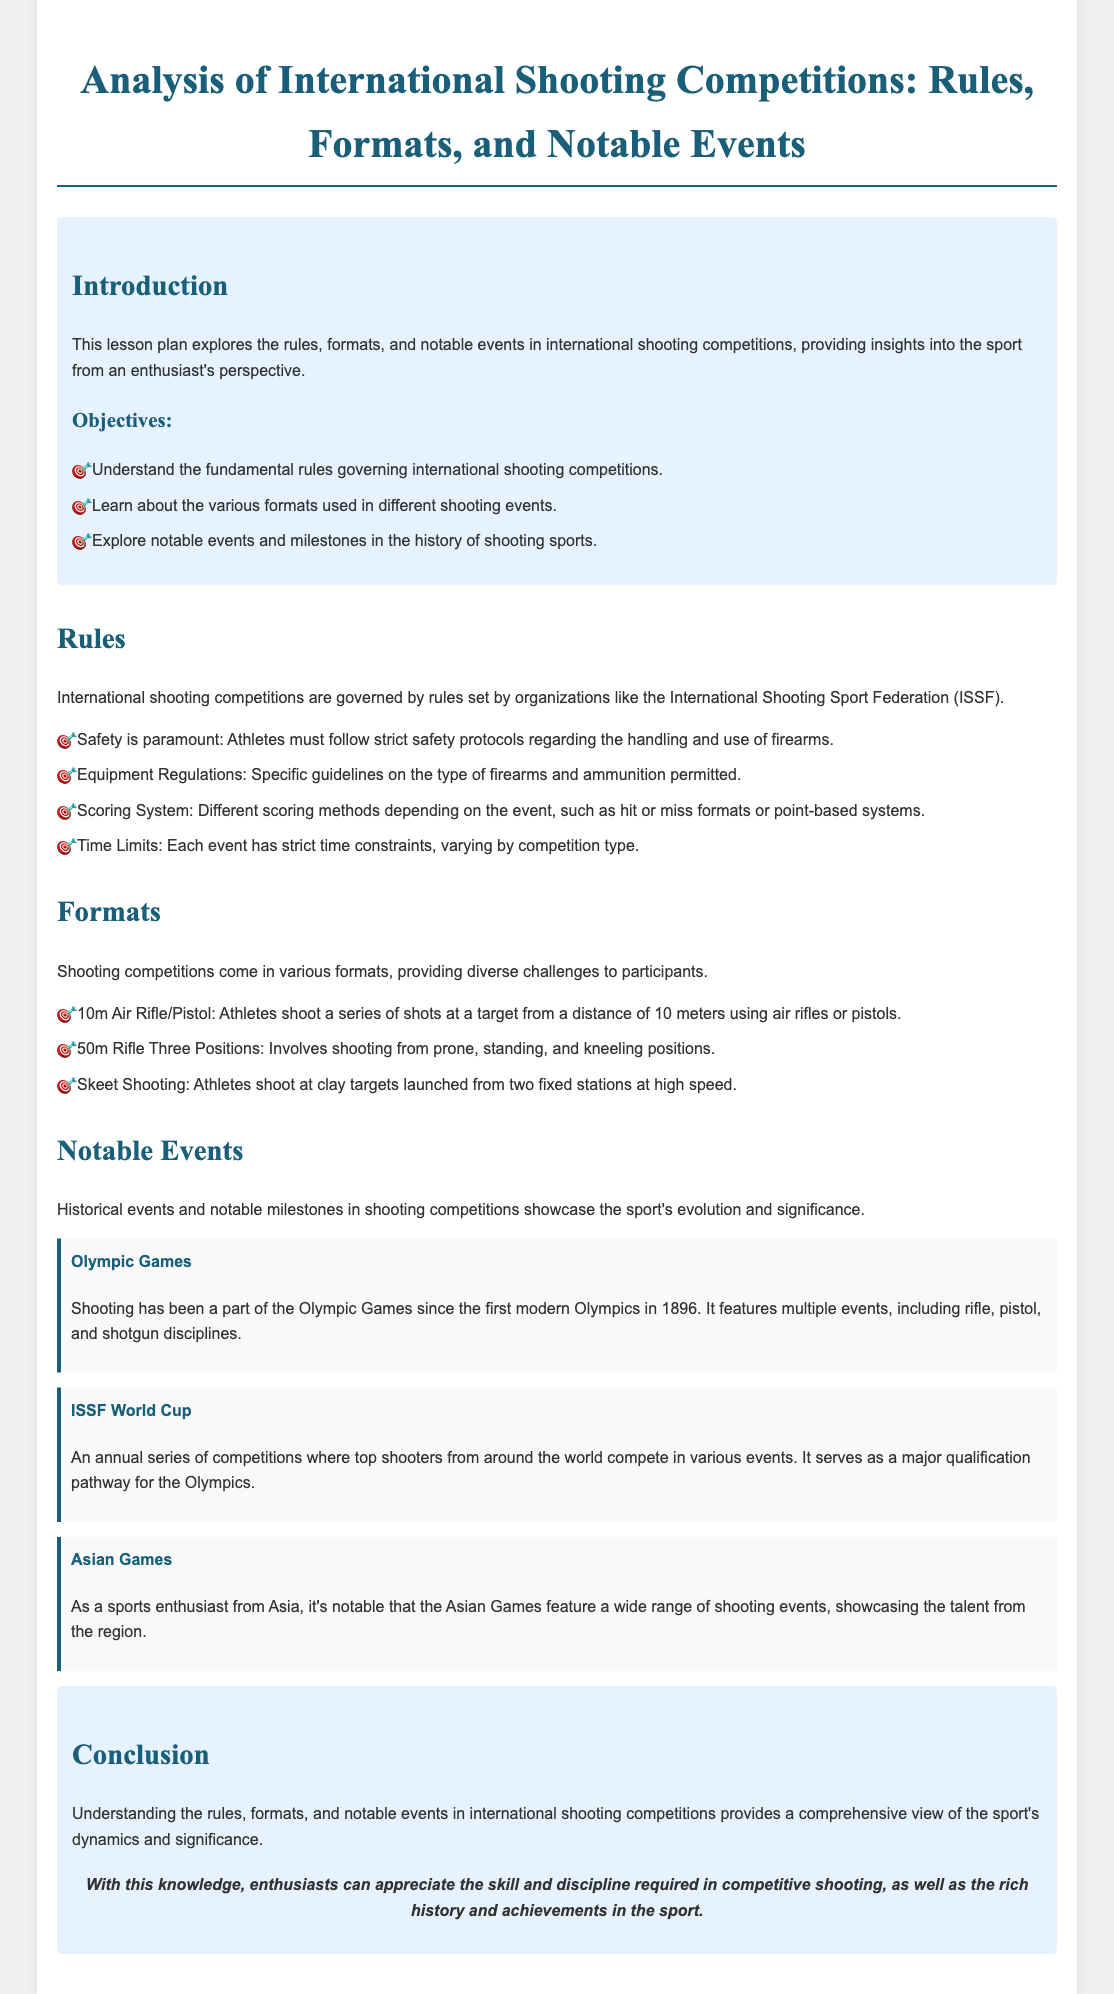What is the title of the lesson plan? The title of the lesson plan is "Analysis of International Shooting Competitions: Rules, Formats, and Notable Events."
Answer: Analysis of International Shooting Competitions: Rules, Formats, and Notable Events Who sets the rules for international shooting competitions? The rules are set by organizations like the International Shooting Sport Federation (ISSF).
Answer: International Shooting Sport Federation (ISSF) What is the distance for the 10m Air Rifle/Pistol event? The event requires athletes to shoot at a target from a distance of 10 meters.
Answer: 10 meters What safety protocol must athletes follow? Athletes must follow strict safety protocols regarding the handling and use of firearms.
Answer: Strict safety protocols When did shooting first become a part of the Olympic Games? Shooting has been part of the Olympic Games since the first modern Olympics in 1896.
Answer: 1896 What notable event serves as a major qualification pathway for the Olympics? The ISSF World Cup serves as a major qualification pathway for the Olympics.
Answer: ISSF World Cup Which regional event features a wide range of shooting events? The Asian Games feature a wide range of shooting events.
Answer: Asian Games What is the objective of understanding shooting event formats? The objective is to learn about the various formats used in different shooting events.
Answer: Learn about formats 